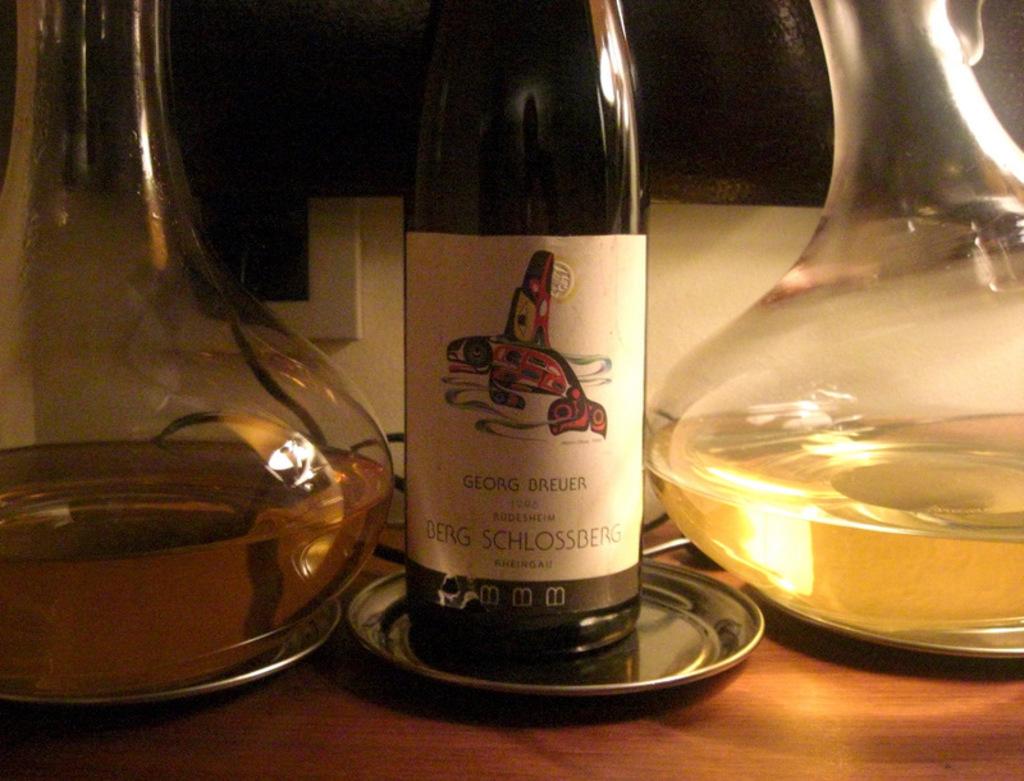Who made the wine on the bottle?
Your answer should be very brief. Georg breuer. What is the first letter of the name of the wine?
Ensure brevity in your answer.  B. 